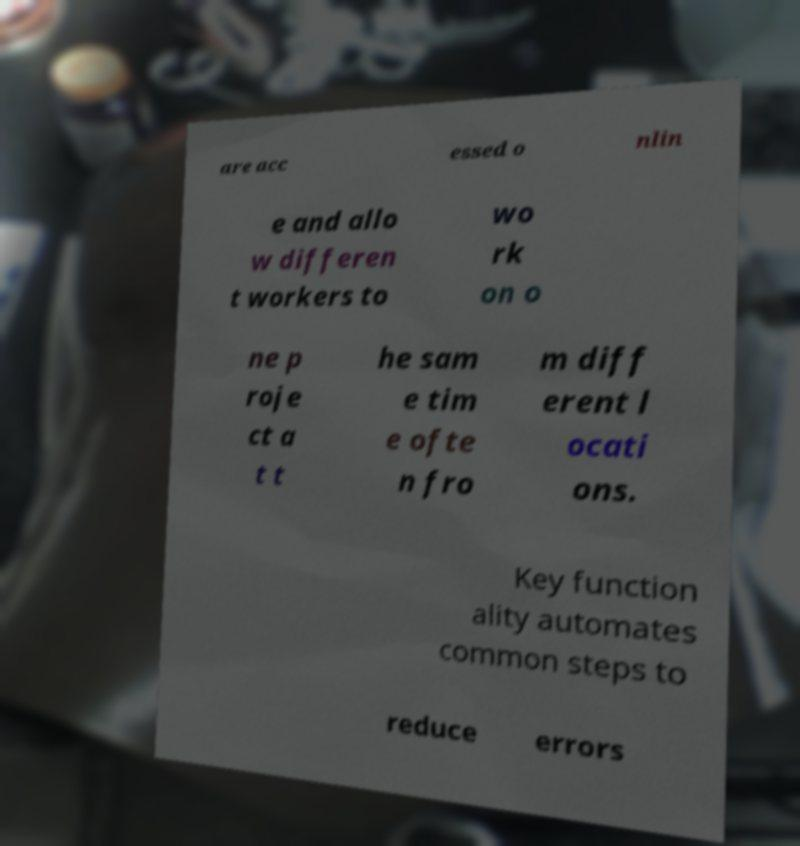Could you extract and type out the text from this image? are acc essed o nlin e and allo w differen t workers to wo rk on o ne p roje ct a t t he sam e tim e ofte n fro m diff erent l ocati ons. Key function ality automates common steps to reduce errors 